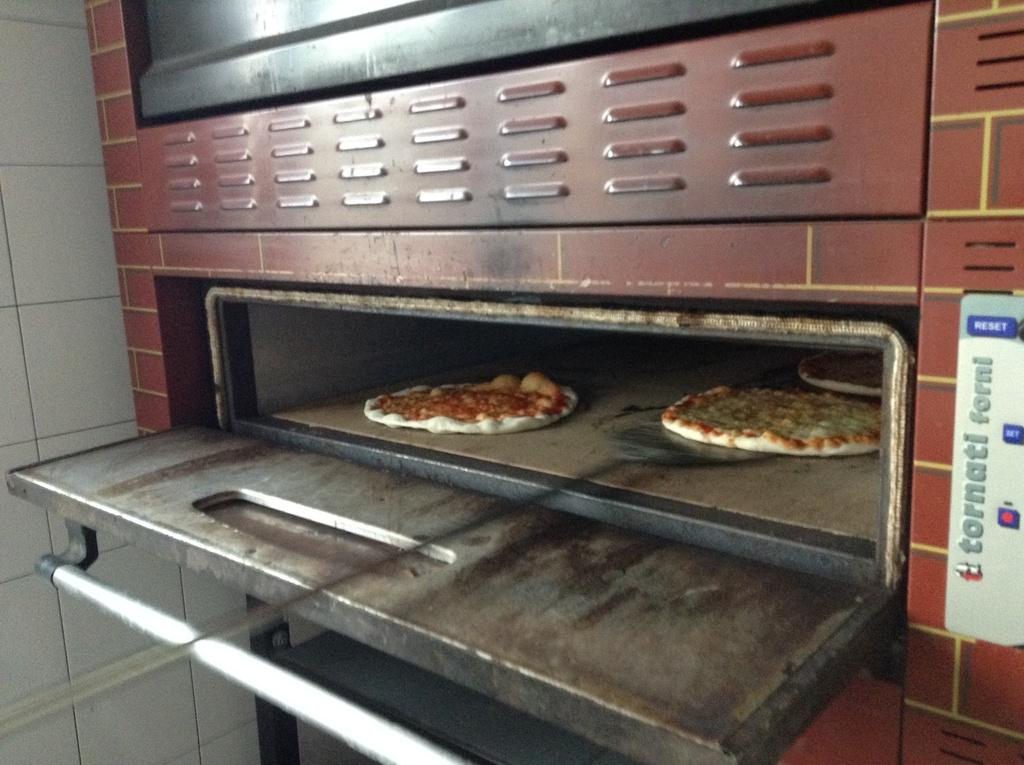<image>
Summarize the visual content of the image. A Tornati Forni oven is baking two pizzas inside 